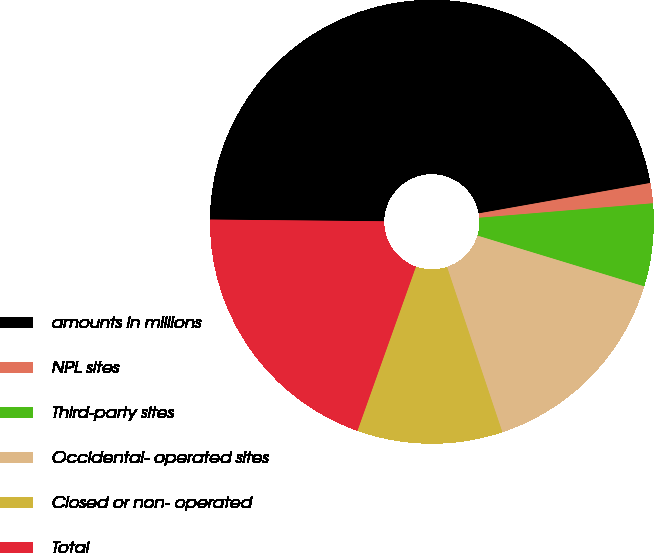<chart> <loc_0><loc_0><loc_500><loc_500><pie_chart><fcel>amounts in millions<fcel>NPL sites<fcel>Third-party sites<fcel>Occidental- operated sites<fcel>Closed or non- operated<fcel>Total<nl><fcel>47.05%<fcel>1.47%<fcel>6.03%<fcel>15.15%<fcel>10.59%<fcel>19.71%<nl></chart> 